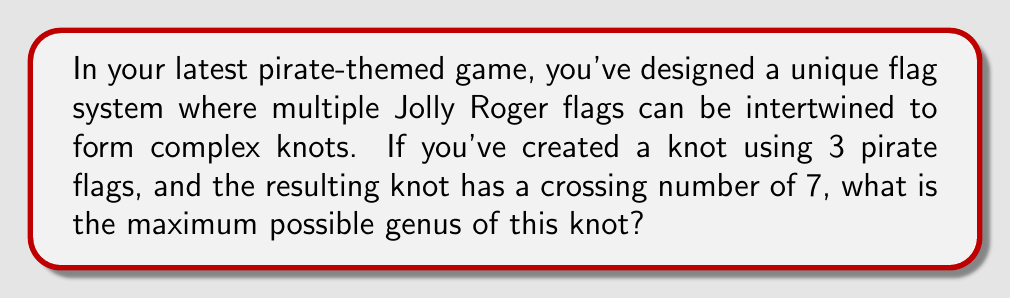What is the answer to this math problem? To solve this problem, we'll follow these steps:

1) First, recall the relationship between the genus $g$, the crossing number $c$, and the number of components $n$ in a link:

   $$g \leq \frac{(c-n+1)}{2}$$

2) In this case, we have:
   - Crossing number $c = 7$
   - Number of components $n = 3$ (since we're using 3 flags)

3) Let's substitute these values into the inequality:

   $$g \leq \frac{(7-3+1)}{2}$$

4) Simplify:
   
   $$g \leq \frac{5}{2}$$

5) Since the genus must be a non-negative integer, the maximum possible genus is the floor of this value:

   $$g \leq \lfloor\frac{5}{2}\rfloor = 2$$

Therefore, the maximum possible genus for this knot is 2.
Answer: 2 